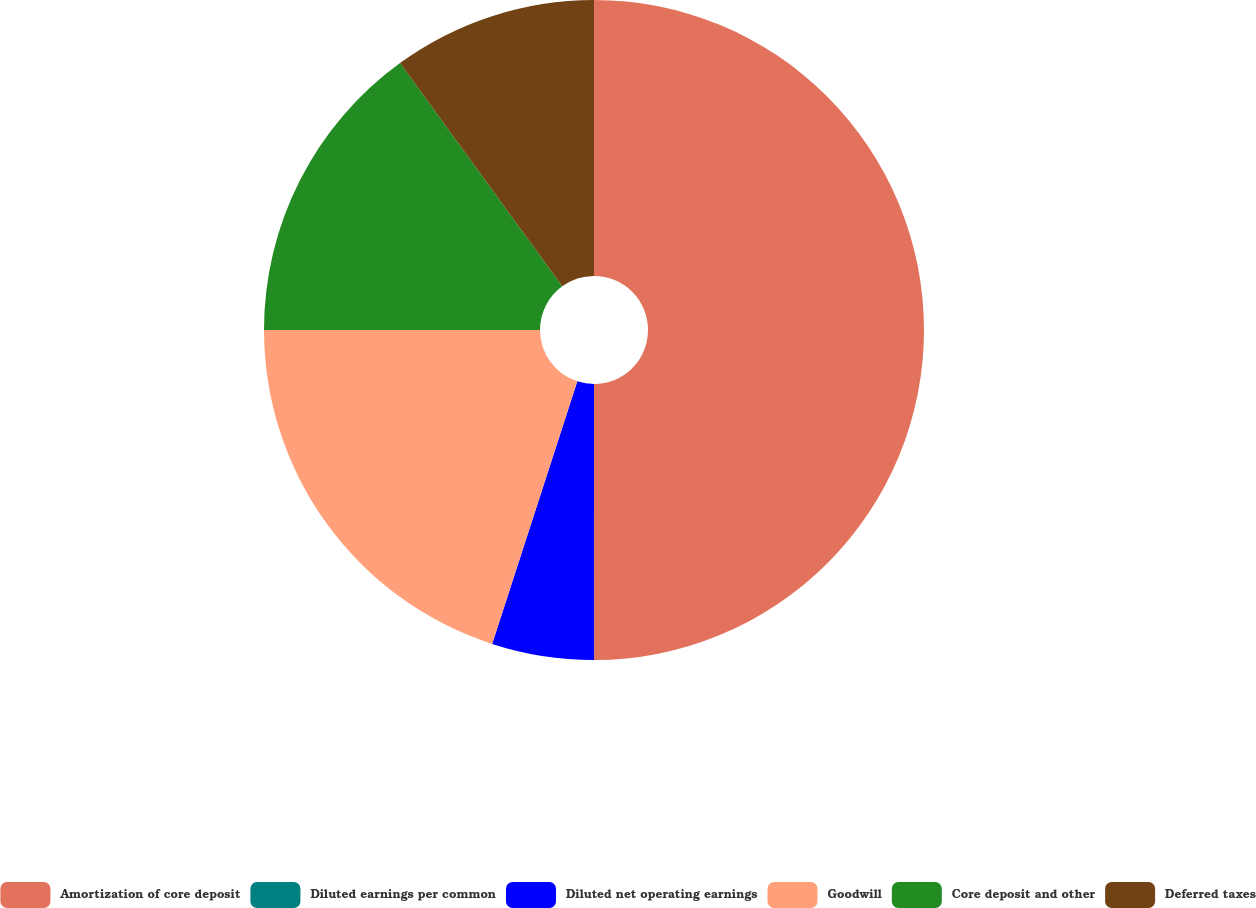Convert chart to OTSL. <chart><loc_0><loc_0><loc_500><loc_500><pie_chart><fcel>Amortization of core deposit<fcel>Diluted earnings per common<fcel>Diluted net operating earnings<fcel>Goodwill<fcel>Core deposit and other<fcel>Deferred taxes<nl><fcel>49.99%<fcel>0.0%<fcel>5.0%<fcel>20.0%<fcel>15.0%<fcel>10.0%<nl></chart> 